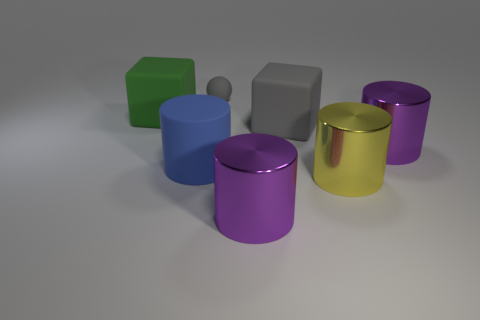Is there anything else that is the same shape as the small object?
Provide a succinct answer. No. What is the material of the yellow cylinder?
Offer a terse response. Metal. What material is the green thing that is the same shape as the big gray thing?
Your answer should be very brief. Rubber. The matte object that is behind the large block to the left of the big blue rubber cylinder is what color?
Your answer should be compact. Gray. What number of shiny objects are purple things or large cylinders?
Provide a succinct answer. 3. Are the green thing and the gray sphere made of the same material?
Give a very brief answer. Yes. What is the material of the gray thing that is to the left of the block that is in front of the green matte thing?
Provide a short and direct response. Rubber. How many small things are yellow cylinders or brown matte objects?
Make the answer very short. 0. What size is the ball?
Make the answer very short. Small. Are there more rubber things in front of the matte ball than red shiny objects?
Keep it short and to the point. Yes. 